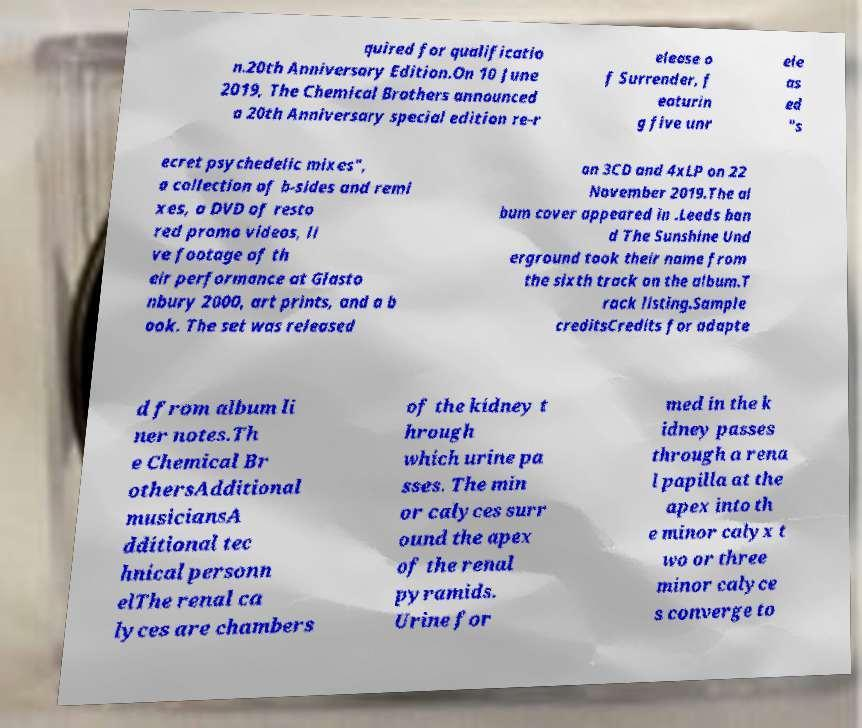I need the written content from this picture converted into text. Can you do that? quired for qualificatio n.20th Anniversary Edition.On 10 June 2019, The Chemical Brothers announced a 20th Anniversary special edition re-r elease o f Surrender, f eaturin g five unr ele as ed "s ecret psychedelic mixes", a collection of b-sides and remi xes, a DVD of resto red promo videos, li ve footage of th eir performance at Glasto nbury 2000, art prints, and a b ook. The set was released on 3CD and 4xLP on 22 November 2019.The al bum cover appeared in .Leeds ban d The Sunshine Und erground took their name from the sixth track on the album.T rack listing.Sample creditsCredits for adapte d from album li ner notes.Th e Chemical Br othersAdditional musiciansA dditional tec hnical personn elThe renal ca lyces are chambers of the kidney t hrough which urine pa sses. The min or calyces surr ound the apex of the renal pyramids. Urine for med in the k idney passes through a rena l papilla at the apex into th e minor calyx t wo or three minor calyce s converge to 